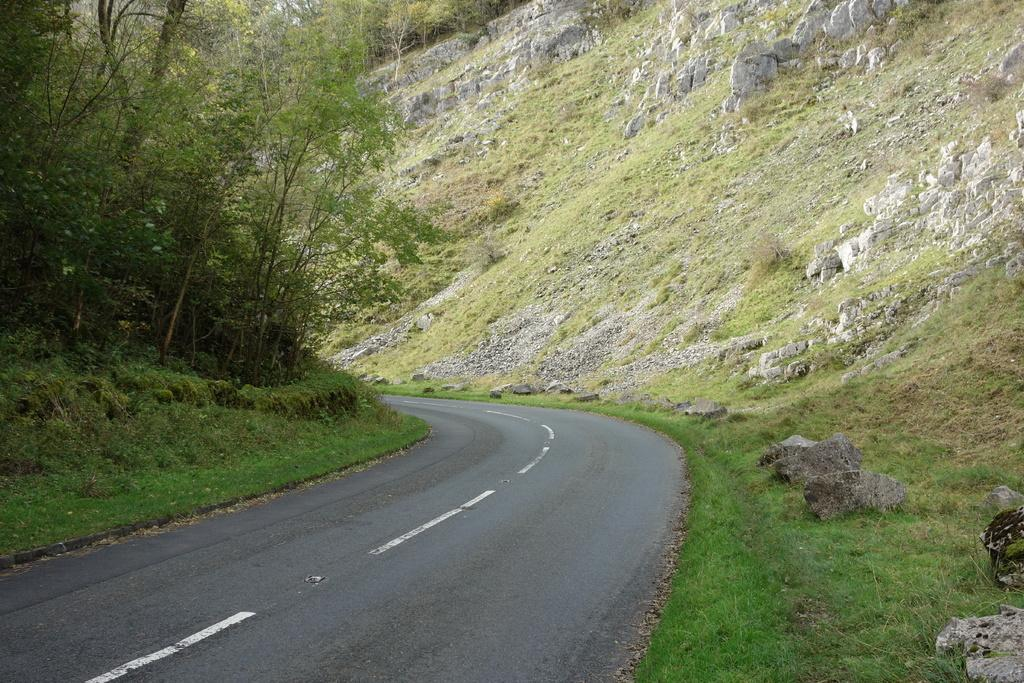What is: What type of surface can be seen in the image? There is a road in the image. What type of vegetation is near the road? There is grass near the road. What other objects can be seen in the image? There are stones and trees visible in the image. Reasoning: Let's think step by step by step in order to produce the conversation. We start by identifying the main subject in the image, which is the road. Then, we expand the conversation to include other elements that are also visible, such as grass, stones, and trees. Each question is designed to elicit a specific detail about the image that is known from the provided facts. Absurd Question/Answer: What type of skirt is being worn by the tree in the image? There are no skirts or people present in the image, as it features a road, grass, stones, and trees. What type of fruit is being used to invent a new technology in the image? There are no fruits or inventions present in the image, as it features a road, grass, stones, and trees. 